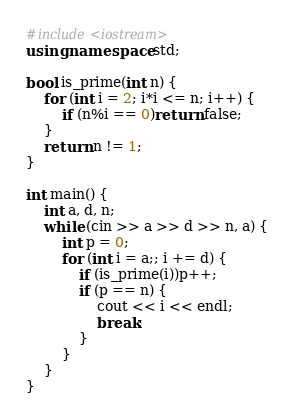<code> <loc_0><loc_0><loc_500><loc_500><_C++_>#include<iostream>
using namespace std;

bool is_prime(int n) {
	for (int i = 2; i*i <= n; i++) {
		if (n%i == 0)return false;
	}
	return n != 1;
}

int main() {
	int a, d, n;
	while (cin >> a >> d >> n, a) {
		int p = 0;
		for (int i = a;; i += d) {
			if (is_prime(i))p++;
			if (p == n) {
				cout << i << endl;
				break;
			}
		}
	}
}</code> 